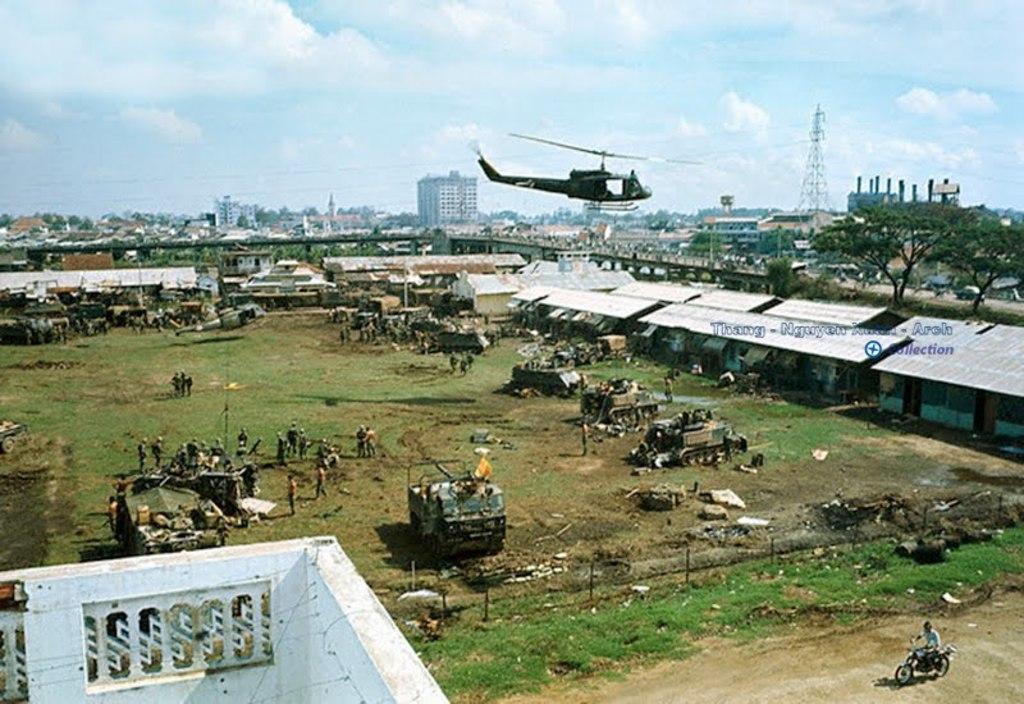Could you give a brief overview of what you see in this image? in this image I can see buildings. There are group of people, bulldozers , other vehicles, there is grass and in the background there is sky. 